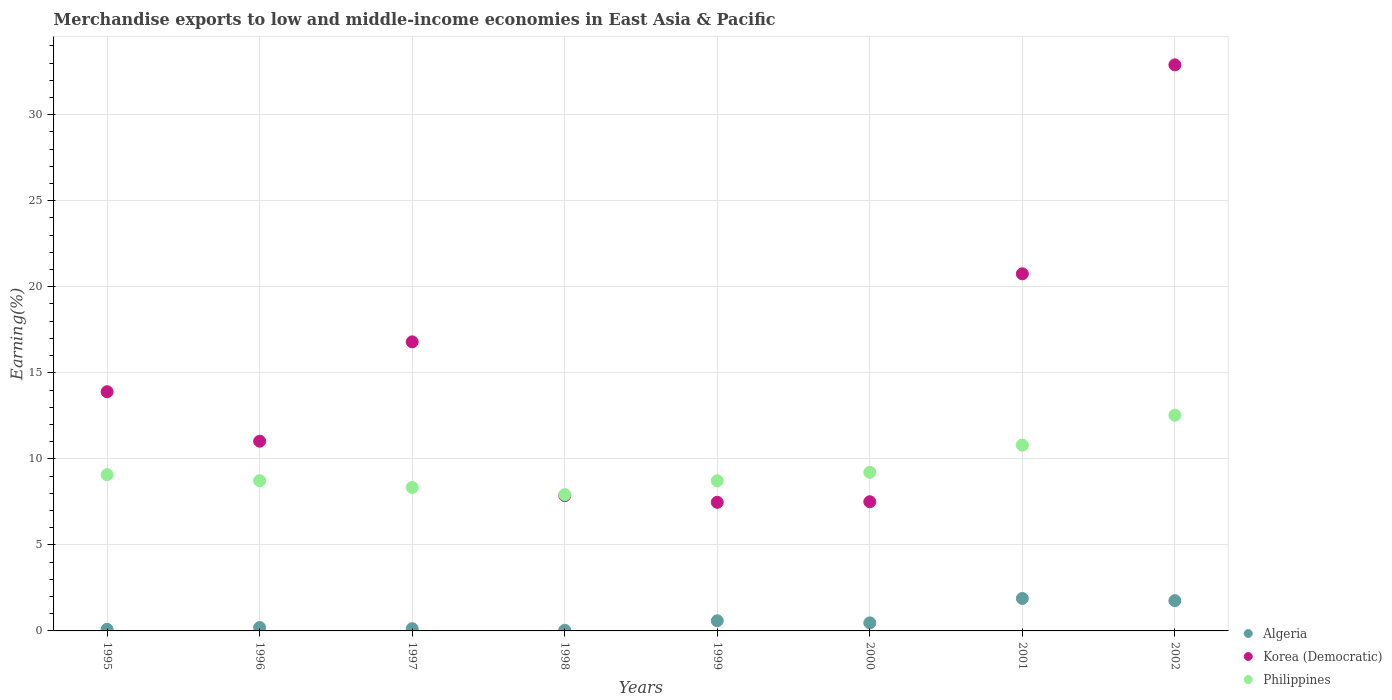Is the number of dotlines equal to the number of legend labels?
Ensure brevity in your answer.  Yes. What is the percentage of amount earned from merchandise exports in Algeria in 1997?
Make the answer very short. 0.13. Across all years, what is the maximum percentage of amount earned from merchandise exports in Korea (Democratic)?
Your response must be concise. 32.9. Across all years, what is the minimum percentage of amount earned from merchandise exports in Algeria?
Offer a terse response. 0.04. What is the total percentage of amount earned from merchandise exports in Philippines in the graph?
Keep it short and to the point. 75.35. What is the difference between the percentage of amount earned from merchandise exports in Algeria in 2000 and that in 2001?
Provide a short and direct response. -1.42. What is the difference between the percentage of amount earned from merchandise exports in Philippines in 1997 and the percentage of amount earned from merchandise exports in Korea (Democratic) in 2001?
Ensure brevity in your answer.  -12.42. What is the average percentage of amount earned from merchandise exports in Korea (Democratic) per year?
Your response must be concise. 14.78. In the year 1997, what is the difference between the percentage of amount earned from merchandise exports in Philippines and percentage of amount earned from merchandise exports in Algeria?
Make the answer very short. 8.21. In how many years, is the percentage of amount earned from merchandise exports in Algeria greater than 1 %?
Ensure brevity in your answer.  2. What is the ratio of the percentage of amount earned from merchandise exports in Algeria in 1996 to that in 1998?
Keep it short and to the point. 5.31. Is the difference between the percentage of amount earned from merchandise exports in Philippines in 1995 and 1996 greater than the difference between the percentage of amount earned from merchandise exports in Algeria in 1995 and 1996?
Ensure brevity in your answer.  Yes. What is the difference between the highest and the second highest percentage of amount earned from merchandise exports in Algeria?
Your answer should be compact. 0.13. What is the difference between the highest and the lowest percentage of amount earned from merchandise exports in Korea (Democratic)?
Give a very brief answer. 25.42. Is the sum of the percentage of amount earned from merchandise exports in Algeria in 1996 and 1998 greater than the maximum percentage of amount earned from merchandise exports in Philippines across all years?
Provide a short and direct response. No. Is it the case that in every year, the sum of the percentage of amount earned from merchandise exports in Algeria and percentage of amount earned from merchandise exports in Korea (Democratic)  is greater than the percentage of amount earned from merchandise exports in Philippines?
Provide a succinct answer. No. Is the percentage of amount earned from merchandise exports in Philippines strictly greater than the percentage of amount earned from merchandise exports in Korea (Democratic) over the years?
Your response must be concise. No. How many years are there in the graph?
Your response must be concise. 8. Where does the legend appear in the graph?
Offer a very short reply. Bottom right. How are the legend labels stacked?
Provide a succinct answer. Vertical. What is the title of the graph?
Your answer should be compact. Merchandise exports to low and middle-income economies in East Asia & Pacific. Does "Kosovo" appear as one of the legend labels in the graph?
Keep it short and to the point. No. What is the label or title of the X-axis?
Provide a succinct answer. Years. What is the label or title of the Y-axis?
Your answer should be very brief. Earning(%). What is the Earning(%) in Algeria in 1995?
Provide a succinct answer. 0.1. What is the Earning(%) of Korea (Democratic) in 1995?
Your answer should be very brief. 13.9. What is the Earning(%) in Philippines in 1995?
Your response must be concise. 9.08. What is the Earning(%) of Algeria in 1996?
Provide a succinct answer. 0.2. What is the Earning(%) of Korea (Democratic) in 1996?
Your answer should be compact. 11.03. What is the Earning(%) of Philippines in 1996?
Your answer should be very brief. 8.73. What is the Earning(%) of Algeria in 1997?
Give a very brief answer. 0.13. What is the Earning(%) of Korea (Democratic) in 1997?
Offer a very short reply. 16.8. What is the Earning(%) of Philippines in 1997?
Offer a terse response. 8.34. What is the Earning(%) of Algeria in 1998?
Your answer should be compact. 0.04. What is the Earning(%) of Korea (Democratic) in 1998?
Offer a very short reply. 7.86. What is the Earning(%) of Philippines in 1998?
Your answer should be compact. 7.92. What is the Earning(%) in Algeria in 1999?
Keep it short and to the point. 0.59. What is the Earning(%) of Korea (Democratic) in 1999?
Your response must be concise. 7.48. What is the Earning(%) of Philippines in 1999?
Offer a terse response. 8.73. What is the Earning(%) in Algeria in 2000?
Your response must be concise. 0.47. What is the Earning(%) in Korea (Democratic) in 2000?
Make the answer very short. 7.51. What is the Earning(%) in Philippines in 2000?
Provide a short and direct response. 9.22. What is the Earning(%) in Algeria in 2001?
Your answer should be compact. 1.89. What is the Earning(%) of Korea (Democratic) in 2001?
Provide a succinct answer. 20.75. What is the Earning(%) of Philippines in 2001?
Give a very brief answer. 10.8. What is the Earning(%) in Algeria in 2002?
Ensure brevity in your answer.  1.76. What is the Earning(%) of Korea (Democratic) in 2002?
Ensure brevity in your answer.  32.9. What is the Earning(%) in Philippines in 2002?
Offer a terse response. 12.54. Across all years, what is the maximum Earning(%) of Algeria?
Your answer should be very brief. 1.89. Across all years, what is the maximum Earning(%) in Korea (Democratic)?
Keep it short and to the point. 32.9. Across all years, what is the maximum Earning(%) of Philippines?
Offer a terse response. 12.54. Across all years, what is the minimum Earning(%) in Algeria?
Provide a succinct answer. 0.04. Across all years, what is the minimum Earning(%) in Korea (Democratic)?
Offer a terse response. 7.48. Across all years, what is the minimum Earning(%) of Philippines?
Offer a terse response. 7.92. What is the total Earning(%) of Algeria in the graph?
Offer a terse response. 5.17. What is the total Earning(%) in Korea (Democratic) in the graph?
Keep it short and to the point. 118.23. What is the total Earning(%) in Philippines in the graph?
Your answer should be compact. 75.35. What is the difference between the Earning(%) of Algeria in 1995 and that in 1996?
Make the answer very short. -0.1. What is the difference between the Earning(%) in Korea (Democratic) in 1995 and that in 1996?
Your response must be concise. 2.88. What is the difference between the Earning(%) in Philippines in 1995 and that in 1996?
Your answer should be compact. 0.35. What is the difference between the Earning(%) of Algeria in 1995 and that in 1997?
Make the answer very short. -0.03. What is the difference between the Earning(%) of Korea (Democratic) in 1995 and that in 1997?
Your answer should be compact. -2.9. What is the difference between the Earning(%) of Philippines in 1995 and that in 1997?
Your response must be concise. 0.74. What is the difference between the Earning(%) of Algeria in 1995 and that in 1998?
Your answer should be compact. 0.06. What is the difference between the Earning(%) of Korea (Democratic) in 1995 and that in 1998?
Offer a very short reply. 6.04. What is the difference between the Earning(%) of Philippines in 1995 and that in 1998?
Ensure brevity in your answer.  1.16. What is the difference between the Earning(%) of Algeria in 1995 and that in 1999?
Your answer should be compact. -0.49. What is the difference between the Earning(%) in Korea (Democratic) in 1995 and that in 1999?
Your response must be concise. 6.43. What is the difference between the Earning(%) of Philippines in 1995 and that in 1999?
Provide a short and direct response. 0.35. What is the difference between the Earning(%) in Algeria in 1995 and that in 2000?
Your response must be concise. -0.37. What is the difference between the Earning(%) of Korea (Democratic) in 1995 and that in 2000?
Offer a very short reply. 6.39. What is the difference between the Earning(%) in Philippines in 1995 and that in 2000?
Offer a terse response. -0.14. What is the difference between the Earning(%) of Algeria in 1995 and that in 2001?
Offer a very short reply. -1.79. What is the difference between the Earning(%) in Korea (Democratic) in 1995 and that in 2001?
Provide a short and direct response. -6.85. What is the difference between the Earning(%) of Philippines in 1995 and that in 2001?
Provide a succinct answer. -1.72. What is the difference between the Earning(%) of Algeria in 1995 and that in 2002?
Your answer should be compact. -1.66. What is the difference between the Earning(%) of Korea (Democratic) in 1995 and that in 2002?
Keep it short and to the point. -19. What is the difference between the Earning(%) in Philippines in 1995 and that in 2002?
Give a very brief answer. -3.46. What is the difference between the Earning(%) of Algeria in 1996 and that in 1997?
Offer a terse response. 0.07. What is the difference between the Earning(%) of Korea (Democratic) in 1996 and that in 1997?
Your response must be concise. -5.77. What is the difference between the Earning(%) in Philippines in 1996 and that in 1997?
Your response must be concise. 0.39. What is the difference between the Earning(%) of Algeria in 1996 and that in 1998?
Your answer should be compact. 0.16. What is the difference between the Earning(%) in Korea (Democratic) in 1996 and that in 1998?
Offer a very short reply. 3.16. What is the difference between the Earning(%) in Philippines in 1996 and that in 1998?
Ensure brevity in your answer.  0.81. What is the difference between the Earning(%) of Algeria in 1996 and that in 1999?
Provide a short and direct response. -0.39. What is the difference between the Earning(%) of Korea (Democratic) in 1996 and that in 1999?
Your answer should be very brief. 3.55. What is the difference between the Earning(%) in Philippines in 1996 and that in 1999?
Your answer should be compact. 0. What is the difference between the Earning(%) of Algeria in 1996 and that in 2000?
Ensure brevity in your answer.  -0.27. What is the difference between the Earning(%) of Korea (Democratic) in 1996 and that in 2000?
Your answer should be very brief. 3.52. What is the difference between the Earning(%) in Philippines in 1996 and that in 2000?
Offer a terse response. -0.49. What is the difference between the Earning(%) of Algeria in 1996 and that in 2001?
Make the answer very short. -1.69. What is the difference between the Earning(%) in Korea (Democratic) in 1996 and that in 2001?
Your answer should be compact. -9.73. What is the difference between the Earning(%) of Philippines in 1996 and that in 2001?
Provide a short and direct response. -2.07. What is the difference between the Earning(%) in Algeria in 1996 and that in 2002?
Offer a terse response. -1.56. What is the difference between the Earning(%) in Korea (Democratic) in 1996 and that in 2002?
Give a very brief answer. -21.87. What is the difference between the Earning(%) in Philippines in 1996 and that in 2002?
Provide a succinct answer. -3.81. What is the difference between the Earning(%) of Algeria in 1997 and that in 1998?
Your answer should be very brief. 0.09. What is the difference between the Earning(%) of Korea (Democratic) in 1997 and that in 1998?
Offer a very short reply. 8.94. What is the difference between the Earning(%) of Philippines in 1997 and that in 1998?
Your answer should be very brief. 0.42. What is the difference between the Earning(%) of Algeria in 1997 and that in 1999?
Your answer should be compact. -0.46. What is the difference between the Earning(%) of Korea (Democratic) in 1997 and that in 1999?
Offer a very short reply. 9.32. What is the difference between the Earning(%) of Philippines in 1997 and that in 1999?
Your answer should be very brief. -0.39. What is the difference between the Earning(%) of Algeria in 1997 and that in 2000?
Give a very brief answer. -0.34. What is the difference between the Earning(%) in Korea (Democratic) in 1997 and that in 2000?
Offer a very short reply. 9.29. What is the difference between the Earning(%) in Philippines in 1997 and that in 2000?
Provide a succinct answer. -0.88. What is the difference between the Earning(%) of Algeria in 1997 and that in 2001?
Your answer should be compact. -1.76. What is the difference between the Earning(%) in Korea (Democratic) in 1997 and that in 2001?
Ensure brevity in your answer.  -3.95. What is the difference between the Earning(%) in Philippines in 1997 and that in 2001?
Your answer should be very brief. -2.46. What is the difference between the Earning(%) of Algeria in 1997 and that in 2002?
Keep it short and to the point. -1.63. What is the difference between the Earning(%) in Korea (Democratic) in 1997 and that in 2002?
Offer a very short reply. -16.1. What is the difference between the Earning(%) in Philippines in 1997 and that in 2002?
Offer a very short reply. -4.2. What is the difference between the Earning(%) in Algeria in 1998 and that in 1999?
Offer a very short reply. -0.55. What is the difference between the Earning(%) of Korea (Democratic) in 1998 and that in 1999?
Your answer should be very brief. 0.39. What is the difference between the Earning(%) in Philippines in 1998 and that in 1999?
Give a very brief answer. -0.81. What is the difference between the Earning(%) in Algeria in 1998 and that in 2000?
Provide a short and direct response. -0.43. What is the difference between the Earning(%) in Korea (Democratic) in 1998 and that in 2000?
Provide a succinct answer. 0.35. What is the difference between the Earning(%) of Philippines in 1998 and that in 2000?
Your response must be concise. -1.3. What is the difference between the Earning(%) in Algeria in 1998 and that in 2001?
Your response must be concise. -1.85. What is the difference between the Earning(%) of Korea (Democratic) in 1998 and that in 2001?
Offer a very short reply. -12.89. What is the difference between the Earning(%) in Philippines in 1998 and that in 2001?
Your answer should be very brief. -2.88. What is the difference between the Earning(%) in Algeria in 1998 and that in 2002?
Your answer should be compact. -1.72. What is the difference between the Earning(%) in Korea (Democratic) in 1998 and that in 2002?
Provide a succinct answer. -25.04. What is the difference between the Earning(%) of Philippines in 1998 and that in 2002?
Keep it short and to the point. -4.62. What is the difference between the Earning(%) in Algeria in 1999 and that in 2000?
Offer a very short reply. 0.12. What is the difference between the Earning(%) of Korea (Democratic) in 1999 and that in 2000?
Ensure brevity in your answer.  -0.03. What is the difference between the Earning(%) in Philippines in 1999 and that in 2000?
Ensure brevity in your answer.  -0.49. What is the difference between the Earning(%) of Algeria in 1999 and that in 2001?
Give a very brief answer. -1.3. What is the difference between the Earning(%) of Korea (Democratic) in 1999 and that in 2001?
Provide a succinct answer. -13.28. What is the difference between the Earning(%) of Philippines in 1999 and that in 2001?
Provide a short and direct response. -2.07. What is the difference between the Earning(%) in Algeria in 1999 and that in 2002?
Offer a very short reply. -1.17. What is the difference between the Earning(%) of Korea (Democratic) in 1999 and that in 2002?
Your answer should be compact. -25.42. What is the difference between the Earning(%) in Philippines in 1999 and that in 2002?
Provide a short and direct response. -3.81. What is the difference between the Earning(%) of Algeria in 2000 and that in 2001?
Your answer should be compact. -1.42. What is the difference between the Earning(%) in Korea (Democratic) in 2000 and that in 2001?
Make the answer very short. -13.25. What is the difference between the Earning(%) in Philippines in 2000 and that in 2001?
Offer a terse response. -1.58. What is the difference between the Earning(%) of Algeria in 2000 and that in 2002?
Provide a succinct answer. -1.29. What is the difference between the Earning(%) of Korea (Democratic) in 2000 and that in 2002?
Provide a succinct answer. -25.39. What is the difference between the Earning(%) of Philippines in 2000 and that in 2002?
Offer a terse response. -3.32. What is the difference between the Earning(%) of Algeria in 2001 and that in 2002?
Keep it short and to the point. 0.13. What is the difference between the Earning(%) of Korea (Democratic) in 2001 and that in 2002?
Keep it short and to the point. -12.14. What is the difference between the Earning(%) of Philippines in 2001 and that in 2002?
Ensure brevity in your answer.  -1.74. What is the difference between the Earning(%) of Algeria in 1995 and the Earning(%) of Korea (Democratic) in 1996?
Give a very brief answer. -10.93. What is the difference between the Earning(%) in Algeria in 1995 and the Earning(%) in Philippines in 1996?
Provide a succinct answer. -8.63. What is the difference between the Earning(%) of Korea (Democratic) in 1995 and the Earning(%) of Philippines in 1996?
Your answer should be very brief. 5.17. What is the difference between the Earning(%) in Algeria in 1995 and the Earning(%) in Korea (Democratic) in 1997?
Your response must be concise. -16.7. What is the difference between the Earning(%) in Algeria in 1995 and the Earning(%) in Philippines in 1997?
Offer a terse response. -8.24. What is the difference between the Earning(%) in Korea (Democratic) in 1995 and the Earning(%) in Philippines in 1997?
Offer a very short reply. 5.56. What is the difference between the Earning(%) of Algeria in 1995 and the Earning(%) of Korea (Democratic) in 1998?
Provide a succinct answer. -7.77. What is the difference between the Earning(%) of Algeria in 1995 and the Earning(%) of Philippines in 1998?
Provide a succinct answer. -7.82. What is the difference between the Earning(%) in Korea (Democratic) in 1995 and the Earning(%) in Philippines in 1998?
Offer a very short reply. 5.99. What is the difference between the Earning(%) in Algeria in 1995 and the Earning(%) in Korea (Democratic) in 1999?
Offer a terse response. -7.38. What is the difference between the Earning(%) of Algeria in 1995 and the Earning(%) of Philippines in 1999?
Ensure brevity in your answer.  -8.63. What is the difference between the Earning(%) in Korea (Democratic) in 1995 and the Earning(%) in Philippines in 1999?
Your answer should be very brief. 5.17. What is the difference between the Earning(%) in Algeria in 1995 and the Earning(%) in Korea (Democratic) in 2000?
Provide a short and direct response. -7.41. What is the difference between the Earning(%) in Algeria in 1995 and the Earning(%) in Philippines in 2000?
Make the answer very short. -9.12. What is the difference between the Earning(%) of Korea (Democratic) in 1995 and the Earning(%) of Philippines in 2000?
Your answer should be very brief. 4.69. What is the difference between the Earning(%) of Algeria in 1995 and the Earning(%) of Korea (Democratic) in 2001?
Give a very brief answer. -20.66. What is the difference between the Earning(%) in Algeria in 1995 and the Earning(%) in Philippines in 2001?
Provide a short and direct response. -10.7. What is the difference between the Earning(%) in Korea (Democratic) in 1995 and the Earning(%) in Philippines in 2001?
Your response must be concise. 3.1. What is the difference between the Earning(%) in Algeria in 1995 and the Earning(%) in Korea (Democratic) in 2002?
Your answer should be very brief. -32.8. What is the difference between the Earning(%) of Algeria in 1995 and the Earning(%) of Philippines in 2002?
Give a very brief answer. -12.44. What is the difference between the Earning(%) of Korea (Democratic) in 1995 and the Earning(%) of Philippines in 2002?
Ensure brevity in your answer.  1.36. What is the difference between the Earning(%) of Algeria in 1996 and the Earning(%) of Korea (Democratic) in 1997?
Provide a succinct answer. -16.6. What is the difference between the Earning(%) in Algeria in 1996 and the Earning(%) in Philippines in 1997?
Give a very brief answer. -8.14. What is the difference between the Earning(%) in Korea (Democratic) in 1996 and the Earning(%) in Philippines in 1997?
Provide a short and direct response. 2.69. What is the difference between the Earning(%) in Algeria in 1996 and the Earning(%) in Korea (Democratic) in 1998?
Your response must be concise. -7.66. What is the difference between the Earning(%) of Algeria in 1996 and the Earning(%) of Philippines in 1998?
Provide a short and direct response. -7.72. What is the difference between the Earning(%) of Korea (Democratic) in 1996 and the Earning(%) of Philippines in 1998?
Offer a terse response. 3.11. What is the difference between the Earning(%) of Algeria in 1996 and the Earning(%) of Korea (Democratic) in 1999?
Make the answer very short. -7.28. What is the difference between the Earning(%) of Algeria in 1996 and the Earning(%) of Philippines in 1999?
Offer a very short reply. -8.53. What is the difference between the Earning(%) in Korea (Democratic) in 1996 and the Earning(%) in Philippines in 1999?
Give a very brief answer. 2.3. What is the difference between the Earning(%) of Algeria in 1996 and the Earning(%) of Korea (Democratic) in 2000?
Provide a succinct answer. -7.31. What is the difference between the Earning(%) in Algeria in 1996 and the Earning(%) in Philippines in 2000?
Keep it short and to the point. -9.02. What is the difference between the Earning(%) in Korea (Democratic) in 1996 and the Earning(%) in Philippines in 2000?
Your response must be concise. 1.81. What is the difference between the Earning(%) in Algeria in 1996 and the Earning(%) in Korea (Democratic) in 2001?
Provide a succinct answer. -20.56. What is the difference between the Earning(%) of Algeria in 1996 and the Earning(%) of Philippines in 2001?
Give a very brief answer. -10.6. What is the difference between the Earning(%) of Korea (Democratic) in 1996 and the Earning(%) of Philippines in 2001?
Your answer should be compact. 0.23. What is the difference between the Earning(%) of Algeria in 1996 and the Earning(%) of Korea (Democratic) in 2002?
Keep it short and to the point. -32.7. What is the difference between the Earning(%) in Algeria in 1996 and the Earning(%) in Philippines in 2002?
Your response must be concise. -12.34. What is the difference between the Earning(%) of Korea (Democratic) in 1996 and the Earning(%) of Philippines in 2002?
Provide a succinct answer. -1.51. What is the difference between the Earning(%) of Algeria in 1997 and the Earning(%) of Korea (Democratic) in 1998?
Make the answer very short. -7.73. What is the difference between the Earning(%) of Algeria in 1997 and the Earning(%) of Philippines in 1998?
Ensure brevity in your answer.  -7.79. What is the difference between the Earning(%) in Korea (Democratic) in 1997 and the Earning(%) in Philippines in 1998?
Provide a short and direct response. 8.88. What is the difference between the Earning(%) in Algeria in 1997 and the Earning(%) in Korea (Democratic) in 1999?
Offer a terse response. -7.34. What is the difference between the Earning(%) of Algeria in 1997 and the Earning(%) of Philippines in 1999?
Provide a short and direct response. -8.6. What is the difference between the Earning(%) in Korea (Democratic) in 1997 and the Earning(%) in Philippines in 1999?
Your response must be concise. 8.07. What is the difference between the Earning(%) in Algeria in 1997 and the Earning(%) in Korea (Democratic) in 2000?
Keep it short and to the point. -7.38. What is the difference between the Earning(%) of Algeria in 1997 and the Earning(%) of Philippines in 2000?
Offer a very short reply. -9.09. What is the difference between the Earning(%) in Korea (Democratic) in 1997 and the Earning(%) in Philippines in 2000?
Provide a short and direct response. 7.58. What is the difference between the Earning(%) of Algeria in 1997 and the Earning(%) of Korea (Democratic) in 2001?
Your response must be concise. -20.62. What is the difference between the Earning(%) of Algeria in 1997 and the Earning(%) of Philippines in 2001?
Make the answer very short. -10.67. What is the difference between the Earning(%) in Korea (Democratic) in 1997 and the Earning(%) in Philippines in 2001?
Provide a short and direct response. 6. What is the difference between the Earning(%) in Algeria in 1997 and the Earning(%) in Korea (Democratic) in 2002?
Your answer should be very brief. -32.77. What is the difference between the Earning(%) of Algeria in 1997 and the Earning(%) of Philippines in 2002?
Make the answer very short. -12.41. What is the difference between the Earning(%) of Korea (Democratic) in 1997 and the Earning(%) of Philippines in 2002?
Provide a short and direct response. 4.26. What is the difference between the Earning(%) of Algeria in 1998 and the Earning(%) of Korea (Democratic) in 1999?
Provide a succinct answer. -7.44. What is the difference between the Earning(%) of Algeria in 1998 and the Earning(%) of Philippines in 1999?
Offer a very short reply. -8.69. What is the difference between the Earning(%) in Korea (Democratic) in 1998 and the Earning(%) in Philippines in 1999?
Give a very brief answer. -0.87. What is the difference between the Earning(%) in Algeria in 1998 and the Earning(%) in Korea (Democratic) in 2000?
Your answer should be compact. -7.47. What is the difference between the Earning(%) of Algeria in 1998 and the Earning(%) of Philippines in 2000?
Your response must be concise. -9.18. What is the difference between the Earning(%) of Korea (Democratic) in 1998 and the Earning(%) of Philippines in 2000?
Your response must be concise. -1.35. What is the difference between the Earning(%) of Algeria in 1998 and the Earning(%) of Korea (Democratic) in 2001?
Provide a succinct answer. -20.72. What is the difference between the Earning(%) of Algeria in 1998 and the Earning(%) of Philippines in 2001?
Offer a terse response. -10.76. What is the difference between the Earning(%) in Korea (Democratic) in 1998 and the Earning(%) in Philippines in 2001?
Give a very brief answer. -2.94. What is the difference between the Earning(%) of Algeria in 1998 and the Earning(%) of Korea (Democratic) in 2002?
Provide a succinct answer. -32.86. What is the difference between the Earning(%) in Algeria in 1998 and the Earning(%) in Philippines in 2002?
Provide a short and direct response. -12.5. What is the difference between the Earning(%) in Korea (Democratic) in 1998 and the Earning(%) in Philippines in 2002?
Keep it short and to the point. -4.68. What is the difference between the Earning(%) in Algeria in 1999 and the Earning(%) in Korea (Democratic) in 2000?
Offer a terse response. -6.92. What is the difference between the Earning(%) of Algeria in 1999 and the Earning(%) of Philippines in 2000?
Give a very brief answer. -8.63. What is the difference between the Earning(%) of Korea (Democratic) in 1999 and the Earning(%) of Philippines in 2000?
Provide a short and direct response. -1.74. What is the difference between the Earning(%) in Algeria in 1999 and the Earning(%) in Korea (Democratic) in 2001?
Keep it short and to the point. -20.16. What is the difference between the Earning(%) in Algeria in 1999 and the Earning(%) in Philippines in 2001?
Offer a terse response. -10.21. What is the difference between the Earning(%) of Korea (Democratic) in 1999 and the Earning(%) of Philippines in 2001?
Your response must be concise. -3.32. What is the difference between the Earning(%) of Algeria in 1999 and the Earning(%) of Korea (Democratic) in 2002?
Your response must be concise. -32.31. What is the difference between the Earning(%) in Algeria in 1999 and the Earning(%) in Philippines in 2002?
Make the answer very short. -11.95. What is the difference between the Earning(%) in Korea (Democratic) in 1999 and the Earning(%) in Philippines in 2002?
Provide a succinct answer. -5.06. What is the difference between the Earning(%) of Algeria in 2000 and the Earning(%) of Korea (Democratic) in 2001?
Offer a very short reply. -20.29. What is the difference between the Earning(%) in Algeria in 2000 and the Earning(%) in Philippines in 2001?
Ensure brevity in your answer.  -10.33. What is the difference between the Earning(%) of Korea (Democratic) in 2000 and the Earning(%) of Philippines in 2001?
Keep it short and to the point. -3.29. What is the difference between the Earning(%) of Algeria in 2000 and the Earning(%) of Korea (Democratic) in 2002?
Make the answer very short. -32.43. What is the difference between the Earning(%) of Algeria in 2000 and the Earning(%) of Philippines in 2002?
Offer a very short reply. -12.07. What is the difference between the Earning(%) in Korea (Democratic) in 2000 and the Earning(%) in Philippines in 2002?
Offer a terse response. -5.03. What is the difference between the Earning(%) of Algeria in 2001 and the Earning(%) of Korea (Democratic) in 2002?
Make the answer very short. -31.01. What is the difference between the Earning(%) in Algeria in 2001 and the Earning(%) in Philippines in 2002?
Your answer should be very brief. -10.65. What is the difference between the Earning(%) in Korea (Democratic) in 2001 and the Earning(%) in Philippines in 2002?
Provide a succinct answer. 8.22. What is the average Earning(%) of Algeria per year?
Make the answer very short. 0.65. What is the average Earning(%) of Korea (Democratic) per year?
Provide a short and direct response. 14.78. What is the average Earning(%) in Philippines per year?
Offer a very short reply. 9.42. In the year 1995, what is the difference between the Earning(%) in Algeria and Earning(%) in Korea (Democratic)?
Provide a short and direct response. -13.81. In the year 1995, what is the difference between the Earning(%) of Algeria and Earning(%) of Philippines?
Give a very brief answer. -8.98. In the year 1995, what is the difference between the Earning(%) in Korea (Democratic) and Earning(%) in Philippines?
Keep it short and to the point. 4.82. In the year 1996, what is the difference between the Earning(%) in Algeria and Earning(%) in Korea (Democratic)?
Provide a succinct answer. -10.83. In the year 1996, what is the difference between the Earning(%) of Algeria and Earning(%) of Philippines?
Offer a terse response. -8.53. In the year 1996, what is the difference between the Earning(%) in Korea (Democratic) and Earning(%) in Philippines?
Give a very brief answer. 2.3. In the year 1997, what is the difference between the Earning(%) of Algeria and Earning(%) of Korea (Democratic)?
Make the answer very short. -16.67. In the year 1997, what is the difference between the Earning(%) in Algeria and Earning(%) in Philippines?
Your response must be concise. -8.21. In the year 1997, what is the difference between the Earning(%) in Korea (Democratic) and Earning(%) in Philippines?
Make the answer very short. 8.46. In the year 1998, what is the difference between the Earning(%) in Algeria and Earning(%) in Korea (Democratic)?
Your answer should be very brief. -7.83. In the year 1998, what is the difference between the Earning(%) in Algeria and Earning(%) in Philippines?
Your response must be concise. -7.88. In the year 1998, what is the difference between the Earning(%) of Korea (Democratic) and Earning(%) of Philippines?
Offer a terse response. -0.05. In the year 1999, what is the difference between the Earning(%) in Algeria and Earning(%) in Korea (Democratic)?
Make the answer very short. -6.89. In the year 1999, what is the difference between the Earning(%) of Algeria and Earning(%) of Philippines?
Your response must be concise. -8.14. In the year 1999, what is the difference between the Earning(%) of Korea (Democratic) and Earning(%) of Philippines?
Your answer should be very brief. -1.25. In the year 2000, what is the difference between the Earning(%) of Algeria and Earning(%) of Korea (Democratic)?
Provide a short and direct response. -7.04. In the year 2000, what is the difference between the Earning(%) of Algeria and Earning(%) of Philippines?
Offer a terse response. -8.75. In the year 2000, what is the difference between the Earning(%) in Korea (Democratic) and Earning(%) in Philippines?
Provide a short and direct response. -1.71. In the year 2001, what is the difference between the Earning(%) of Algeria and Earning(%) of Korea (Democratic)?
Your response must be concise. -18.87. In the year 2001, what is the difference between the Earning(%) in Algeria and Earning(%) in Philippines?
Provide a short and direct response. -8.91. In the year 2001, what is the difference between the Earning(%) in Korea (Democratic) and Earning(%) in Philippines?
Ensure brevity in your answer.  9.96. In the year 2002, what is the difference between the Earning(%) of Algeria and Earning(%) of Korea (Democratic)?
Ensure brevity in your answer.  -31.14. In the year 2002, what is the difference between the Earning(%) in Algeria and Earning(%) in Philippines?
Your answer should be very brief. -10.78. In the year 2002, what is the difference between the Earning(%) of Korea (Democratic) and Earning(%) of Philippines?
Your answer should be compact. 20.36. What is the ratio of the Earning(%) of Algeria in 1995 to that in 1996?
Ensure brevity in your answer.  0.48. What is the ratio of the Earning(%) of Korea (Democratic) in 1995 to that in 1996?
Provide a succinct answer. 1.26. What is the ratio of the Earning(%) of Philippines in 1995 to that in 1996?
Your answer should be compact. 1.04. What is the ratio of the Earning(%) in Algeria in 1995 to that in 1997?
Offer a very short reply. 0.73. What is the ratio of the Earning(%) of Korea (Democratic) in 1995 to that in 1997?
Provide a short and direct response. 0.83. What is the ratio of the Earning(%) of Philippines in 1995 to that in 1997?
Offer a very short reply. 1.09. What is the ratio of the Earning(%) in Algeria in 1995 to that in 1998?
Your response must be concise. 2.57. What is the ratio of the Earning(%) in Korea (Democratic) in 1995 to that in 1998?
Your answer should be compact. 1.77. What is the ratio of the Earning(%) of Philippines in 1995 to that in 1998?
Offer a terse response. 1.15. What is the ratio of the Earning(%) of Algeria in 1995 to that in 1999?
Provide a succinct answer. 0.16. What is the ratio of the Earning(%) in Korea (Democratic) in 1995 to that in 1999?
Your response must be concise. 1.86. What is the ratio of the Earning(%) of Philippines in 1995 to that in 1999?
Provide a short and direct response. 1.04. What is the ratio of the Earning(%) in Algeria in 1995 to that in 2000?
Provide a succinct answer. 0.2. What is the ratio of the Earning(%) of Korea (Democratic) in 1995 to that in 2000?
Make the answer very short. 1.85. What is the ratio of the Earning(%) in Philippines in 1995 to that in 2000?
Make the answer very short. 0.99. What is the ratio of the Earning(%) in Algeria in 1995 to that in 2001?
Ensure brevity in your answer.  0.05. What is the ratio of the Earning(%) in Korea (Democratic) in 1995 to that in 2001?
Provide a short and direct response. 0.67. What is the ratio of the Earning(%) of Philippines in 1995 to that in 2001?
Offer a very short reply. 0.84. What is the ratio of the Earning(%) in Algeria in 1995 to that in 2002?
Provide a short and direct response. 0.05. What is the ratio of the Earning(%) of Korea (Democratic) in 1995 to that in 2002?
Provide a short and direct response. 0.42. What is the ratio of the Earning(%) of Philippines in 1995 to that in 2002?
Your answer should be very brief. 0.72. What is the ratio of the Earning(%) in Algeria in 1996 to that in 1997?
Give a very brief answer. 1.51. What is the ratio of the Earning(%) in Korea (Democratic) in 1996 to that in 1997?
Provide a short and direct response. 0.66. What is the ratio of the Earning(%) in Philippines in 1996 to that in 1997?
Your answer should be compact. 1.05. What is the ratio of the Earning(%) of Algeria in 1996 to that in 1998?
Provide a short and direct response. 5.31. What is the ratio of the Earning(%) in Korea (Democratic) in 1996 to that in 1998?
Your response must be concise. 1.4. What is the ratio of the Earning(%) of Philippines in 1996 to that in 1998?
Provide a succinct answer. 1.1. What is the ratio of the Earning(%) in Algeria in 1996 to that in 1999?
Provide a short and direct response. 0.34. What is the ratio of the Earning(%) in Korea (Democratic) in 1996 to that in 1999?
Provide a succinct answer. 1.47. What is the ratio of the Earning(%) of Algeria in 1996 to that in 2000?
Offer a terse response. 0.42. What is the ratio of the Earning(%) of Korea (Democratic) in 1996 to that in 2000?
Your answer should be very brief. 1.47. What is the ratio of the Earning(%) in Philippines in 1996 to that in 2000?
Offer a very short reply. 0.95. What is the ratio of the Earning(%) in Algeria in 1996 to that in 2001?
Your response must be concise. 0.1. What is the ratio of the Earning(%) in Korea (Democratic) in 1996 to that in 2001?
Offer a very short reply. 0.53. What is the ratio of the Earning(%) in Philippines in 1996 to that in 2001?
Provide a short and direct response. 0.81. What is the ratio of the Earning(%) of Algeria in 1996 to that in 2002?
Keep it short and to the point. 0.11. What is the ratio of the Earning(%) in Korea (Democratic) in 1996 to that in 2002?
Make the answer very short. 0.34. What is the ratio of the Earning(%) in Philippines in 1996 to that in 2002?
Your answer should be compact. 0.7. What is the ratio of the Earning(%) in Algeria in 1997 to that in 1998?
Provide a succinct answer. 3.51. What is the ratio of the Earning(%) of Korea (Democratic) in 1997 to that in 1998?
Your response must be concise. 2.14. What is the ratio of the Earning(%) of Philippines in 1997 to that in 1998?
Provide a short and direct response. 1.05. What is the ratio of the Earning(%) of Algeria in 1997 to that in 1999?
Provide a succinct answer. 0.22. What is the ratio of the Earning(%) of Korea (Democratic) in 1997 to that in 1999?
Ensure brevity in your answer.  2.25. What is the ratio of the Earning(%) of Philippines in 1997 to that in 1999?
Keep it short and to the point. 0.96. What is the ratio of the Earning(%) of Algeria in 1997 to that in 2000?
Provide a short and direct response. 0.28. What is the ratio of the Earning(%) of Korea (Democratic) in 1997 to that in 2000?
Make the answer very short. 2.24. What is the ratio of the Earning(%) of Philippines in 1997 to that in 2000?
Offer a very short reply. 0.9. What is the ratio of the Earning(%) in Algeria in 1997 to that in 2001?
Provide a succinct answer. 0.07. What is the ratio of the Earning(%) in Korea (Democratic) in 1997 to that in 2001?
Your answer should be compact. 0.81. What is the ratio of the Earning(%) in Philippines in 1997 to that in 2001?
Provide a succinct answer. 0.77. What is the ratio of the Earning(%) of Algeria in 1997 to that in 2002?
Offer a very short reply. 0.07. What is the ratio of the Earning(%) of Korea (Democratic) in 1997 to that in 2002?
Ensure brevity in your answer.  0.51. What is the ratio of the Earning(%) of Philippines in 1997 to that in 2002?
Your answer should be compact. 0.67. What is the ratio of the Earning(%) of Algeria in 1998 to that in 1999?
Provide a short and direct response. 0.06. What is the ratio of the Earning(%) of Korea (Democratic) in 1998 to that in 1999?
Provide a short and direct response. 1.05. What is the ratio of the Earning(%) in Philippines in 1998 to that in 1999?
Provide a short and direct response. 0.91. What is the ratio of the Earning(%) in Algeria in 1998 to that in 2000?
Your answer should be very brief. 0.08. What is the ratio of the Earning(%) in Korea (Democratic) in 1998 to that in 2000?
Your response must be concise. 1.05. What is the ratio of the Earning(%) of Philippines in 1998 to that in 2000?
Your answer should be very brief. 0.86. What is the ratio of the Earning(%) of Algeria in 1998 to that in 2001?
Give a very brief answer. 0.02. What is the ratio of the Earning(%) in Korea (Democratic) in 1998 to that in 2001?
Your response must be concise. 0.38. What is the ratio of the Earning(%) of Philippines in 1998 to that in 2001?
Make the answer very short. 0.73. What is the ratio of the Earning(%) of Algeria in 1998 to that in 2002?
Ensure brevity in your answer.  0.02. What is the ratio of the Earning(%) in Korea (Democratic) in 1998 to that in 2002?
Offer a very short reply. 0.24. What is the ratio of the Earning(%) in Philippines in 1998 to that in 2002?
Offer a very short reply. 0.63. What is the ratio of the Earning(%) in Algeria in 1999 to that in 2000?
Your response must be concise. 1.26. What is the ratio of the Earning(%) of Korea (Democratic) in 1999 to that in 2000?
Ensure brevity in your answer.  1. What is the ratio of the Earning(%) of Philippines in 1999 to that in 2000?
Offer a terse response. 0.95. What is the ratio of the Earning(%) of Algeria in 1999 to that in 2001?
Provide a short and direct response. 0.31. What is the ratio of the Earning(%) of Korea (Democratic) in 1999 to that in 2001?
Keep it short and to the point. 0.36. What is the ratio of the Earning(%) of Philippines in 1999 to that in 2001?
Provide a succinct answer. 0.81. What is the ratio of the Earning(%) of Algeria in 1999 to that in 2002?
Ensure brevity in your answer.  0.34. What is the ratio of the Earning(%) of Korea (Democratic) in 1999 to that in 2002?
Offer a terse response. 0.23. What is the ratio of the Earning(%) of Philippines in 1999 to that in 2002?
Offer a very short reply. 0.7. What is the ratio of the Earning(%) of Algeria in 2000 to that in 2001?
Make the answer very short. 0.25. What is the ratio of the Earning(%) in Korea (Democratic) in 2000 to that in 2001?
Offer a very short reply. 0.36. What is the ratio of the Earning(%) of Philippines in 2000 to that in 2001?
Give a very brief answer. 0.85. What is the ratio of the Earning(%) of Algeria in 2000 to that in 2002?
Offer a very short reply. 0.27. What is the ratio of the Earning(%) of Korea (Democratic) in 2000 to that in 2002?
Offer a very short reply. 0.23. What is the ratio of the Earning(%) in Philippines in 2000 to that in 2002?
Provide a short and direct response. 0.74. What is the ratio of the Earning(%) in Algeria in 2001 to that in 2002?
Your answer should be compact. 1.07. What is the ratio of the Earning(%) of Korea (Democratic) in 2001 to that in 2002?
Keep it short and to the point. 0.63. What is the ratio of the Earning(%) in Philippines in 2001 to that in 2002?
Offer a very short reply. 0.86. What is the difference between the highest and the second highest Earning(%) of Algeria?
Ensure brevity in your answer.  0.13. What is the difference between the highest and the second highest Earning(%) of Korea (Democratic)?
Offer a very short reply. 12.14. What is the difference between the highest and the second highest Earning(%) of Philippines?
Your response must be concise. 1.74. What is the difference between the highest and the lowest Earning(%) in Algeria?
Offer a terse response. 1.85. What is the difference between the highest and the lowest Earning(%) in Korea (Democratic)?
Your response must be concise. 25.42. What is the difference between the highest and the lowest Earning(%) of Philippines?
Provide a succinct answer. 4.62. 